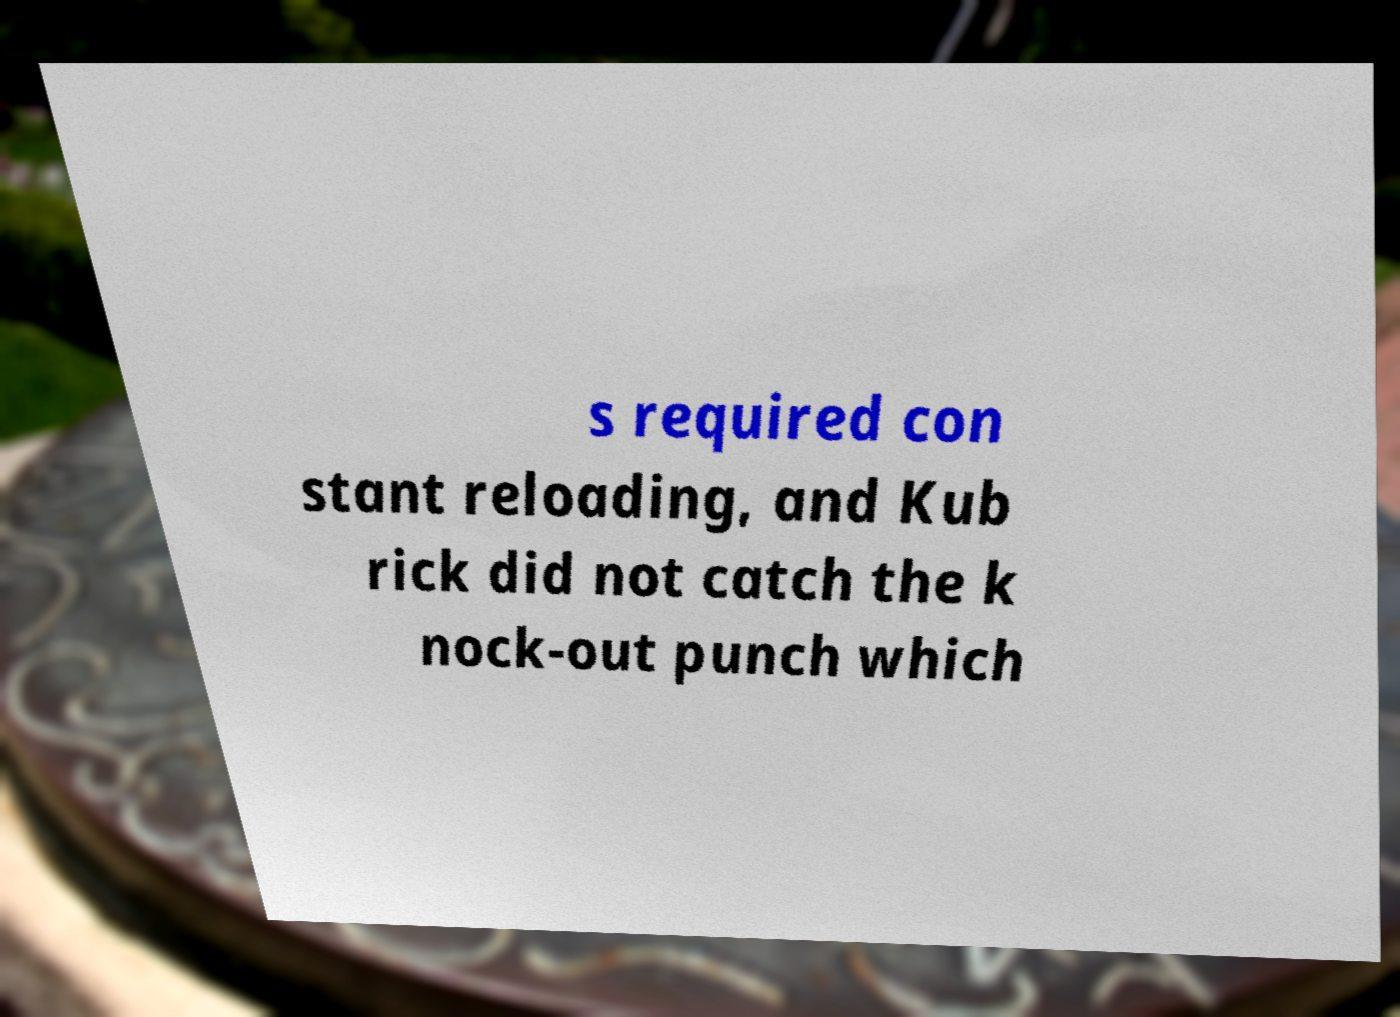Can you read and provide the text displayed in the image?This photo seems to have some interesting text. Can you extract and type it out for me? s required con stant reloading, and Kub rick did not catch the k nock-out punch which 